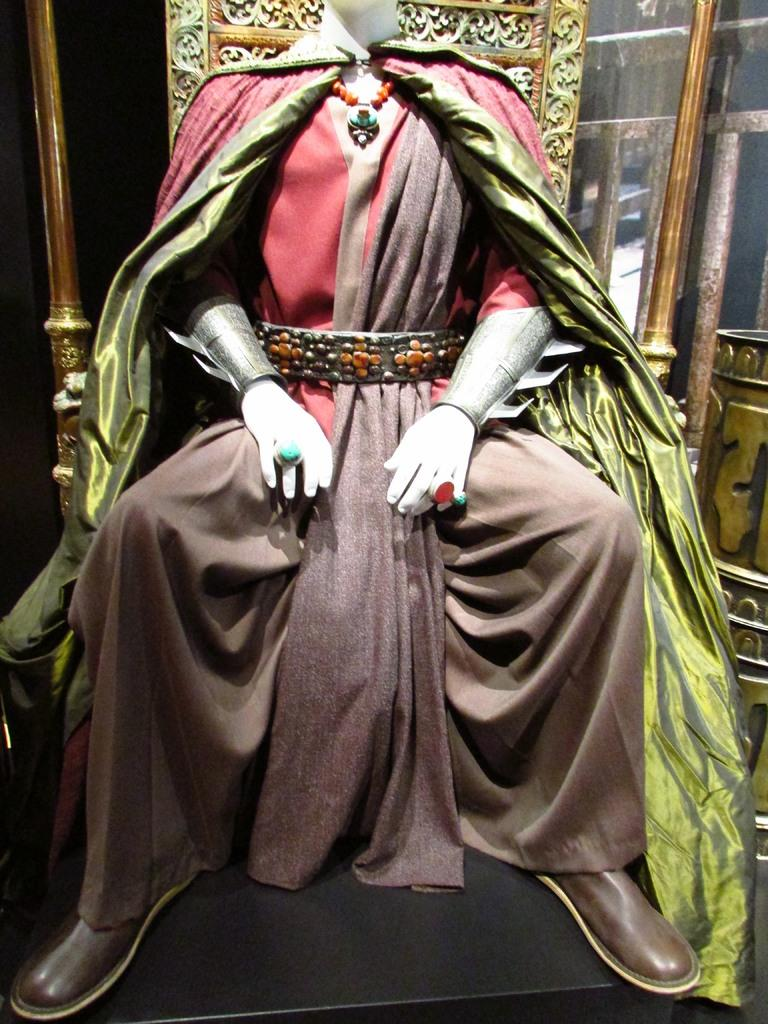What is the main subject of the image? There is a statue of a person in the image. What is the person in the statue wearing? The person is wearing ornaments. What is the person in the statue doing? The person is sitting on a chair. What type of material can be seen in the image? There is cloth visible in the image. What can be seen in the background of the image? There are objects in the background of the image. What type of linen is being offered to the person in the image? There is no linen being offered to the person in the image; the statue is stationary and not interacting with any objects. What type of cabbage is growing in the background of the image? There is no cabbage present in the image; the objects in the background are not specified. 